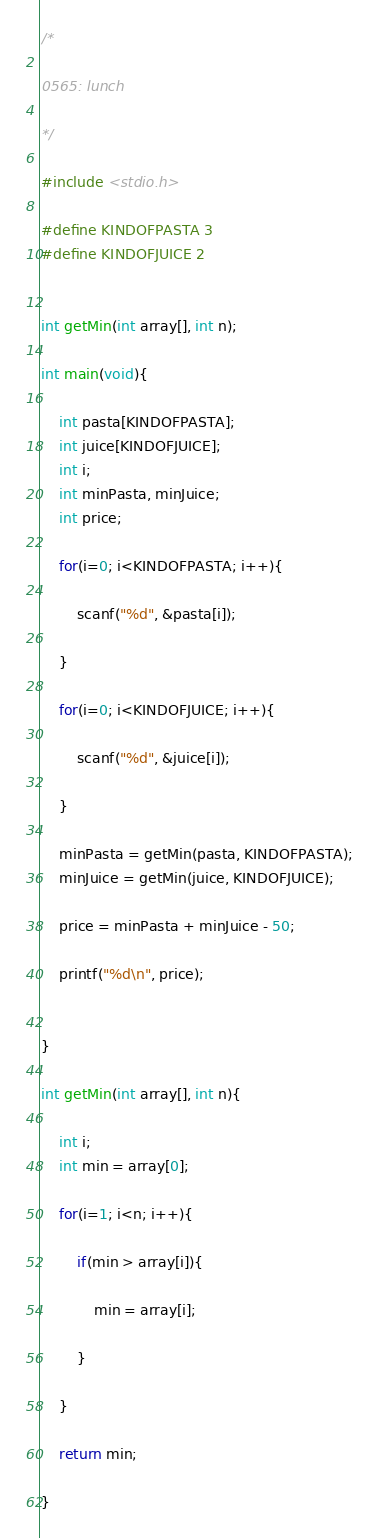Convert code to text. <code><loc_0><loc_0><loc_500><loc_500><_C_>/*

0565: lunch

*/

#include <stdio.h>

#define KINDOFPASTA 3
#define KINDOFJUICE 2


int getMin(int array[], int n);

int main(void){
	
	int pasta[KINDOFPASTA];
	int juice[KINDOFJUICE];
	int i;
	int minPasta, minJuice;
	int price;
	
	for(i=0; i<KINDOFPASTA; i++){
		
		scanf("%d", &pasta[i]);
		
	}
	
	for(i=0; i<KINDOFJUICE; i++){
		
		scanf("%d", &juice[i]);
		
	}
	
	minPasta = getMin(pasta, KINDOFPASTA);
	minJuice = getMin(juice, KINDOFJUICE);
	
	price = minPasta + minJuice - 50;
	
	printf("%d\n", price);
	
	
}

int getMin(int array[], int n){
	
	int i;
	int min = array[0];
	
	for(i=1; i<n; i++){
		
		if(min > array[i]){
			
			min = array[i];
			
		}
		
	}
	
	return min;
	
}</code> 